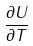Convert formula to latex. <formula><loc_0><loc_0><loc_500><loc_500>\frac { \partial U } { \partial T }</formula> 